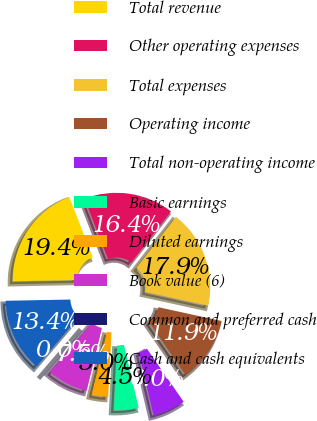<chart> <loc_0><loc_0><loc_500><loc_500><pie_chart><fcel>Total revenue<fcel>Other operating expenses<fcel>Total expenses<fcel>Operating income<fcel>Total non-operating income<fcel>Basic earnings<fcel>Diluted earnings<fcel>Book value (6)<fcel>Common and preferred cash<fcel>Cash and cash equivalents<nl><fcel>19.4%<fcel>16.42%<fcel>17.91%<fcel>11.94%<fcel>5.97%<fcel>4.48%<fcel>2.99%<fcel>7.46%<fcel>0.0%<fcel>13.43%<nl></chart> 